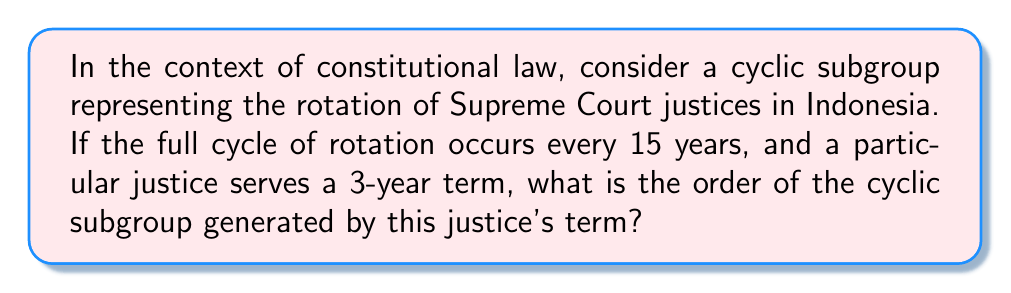Teach me how to tackle this problem. To solve this problem, we need to apply the concept of cyclic subgroups from abstract algebra to a constitutional law scenario. Let's break it down step-by-step:

1) In abstract algebra, a cyclic subgroup is generated by a single element. In this case, the generating element is the 3-year term of a justice.

2) The order of a cyclic subgroup is the smallest positive integer $n$ such that $a^n = e$, where $a$ is the generating element and $e$ is the identity element.

3) In our context, this means we need to find how many 3-year terms it takes to complete a full 15-year cycle.

4) We can express this mathematically as:

   $$ 3x \equiv 0 \pmod{15} $$

   where $x$ is the number of terms we're looking for.

5) To solve this, we need to find the least common multiple (LCM) of 3 and 15:

   $$ LCM(3,15) = \frac{3 \times 15}{GCD(3,15)} = \frac{45}{3} = 15 $$

6) The solution to our congruence is:

   $$ x = \frac{15}{3} = 5 $$

7) This means that after 5 terms, we complete a full cycle and return to the starting point.

Therefore, the order of the cyclic subgroup is 5.
Answer: The order of the cyclic subgroup is 5. 